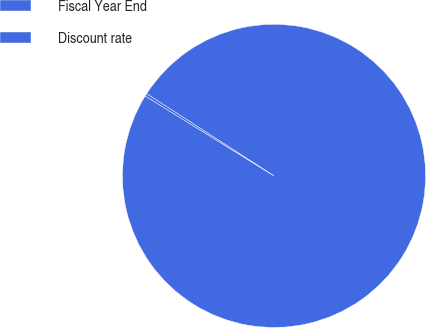Convert chart to OTSL. <chart><loc_0><loc_0><loc_500><loc_500><pie_chart><fcel>Fiscal Year End<fcel>Discount rate<nl><fcel>99.72%<fcel>0.28%<nl></chart> 